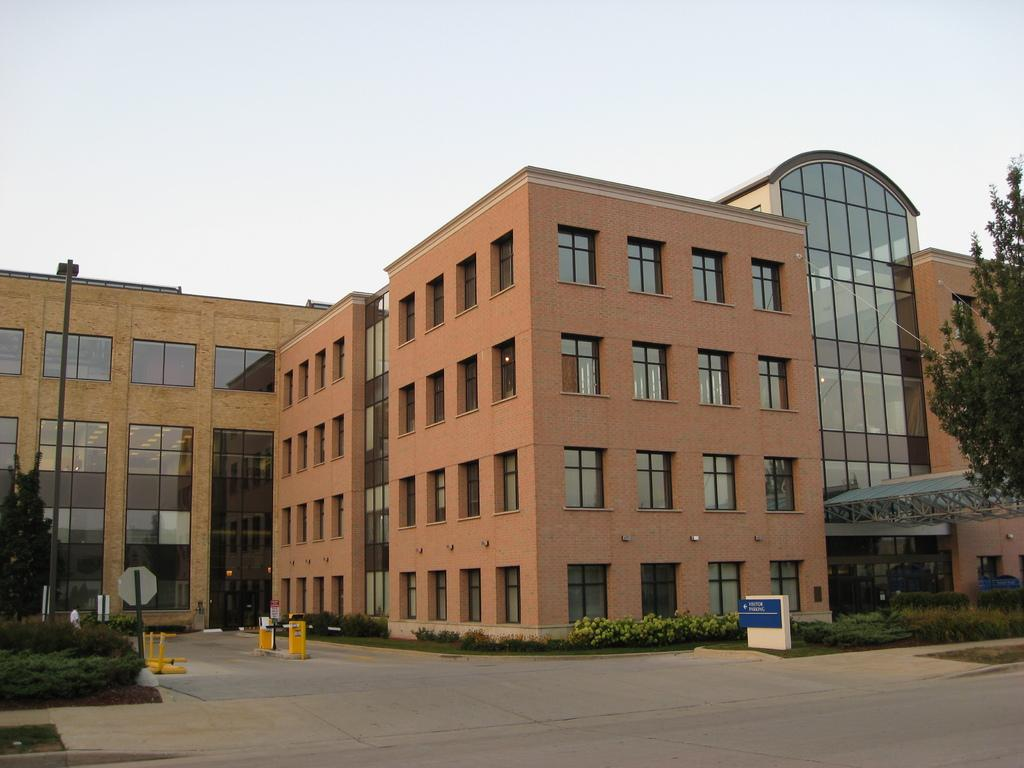What type of structure is present in the image? There is a building in the image. What feature of the building is mentioned in the facts? The building has many windows and glass panels. What is located in front of the building? There are plants and a garden in front of the building. What can be seen above the building? The sky is visible above the building. Can you see any corks floating in the garden in the image? There are no corks present in the image, as it features a building with a garden and plants in front of it. 